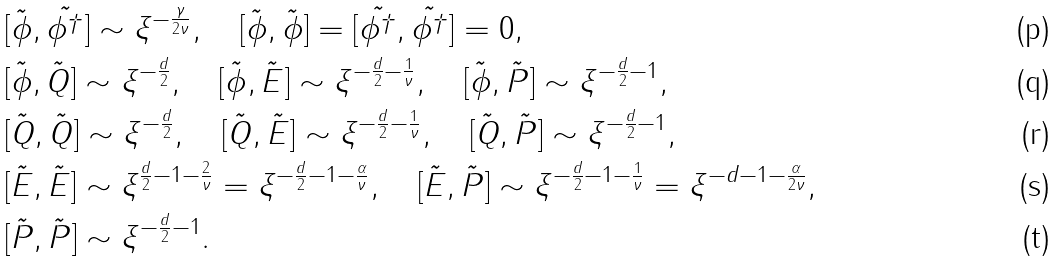<formula> <loc_0><loc_0><loc_500><loc_500>& [ \tilde { \phi } , \tilde { \phi ^ { \dagger } } ] \sim \xi ^ { - \frac { \gamma } { 2 \nu } } , \quad [ \tilde { \phi } , \tilde { \phi } ] = [ \tilde { \phi ^ { \dagger } } , \tilde { \phi ^ { \dagger } } ] = 0 , \\ & [ \tilde { \phi } , \tilde { Q } ] \sim \xi ^ { - \frac { d } { 2 } } , \quad [ \tilde { \phi } , \tilde { E } ] \sim \xi ^ { - \frac { d } { 2 } - \frac { 1 } { \nu } } , \quad [ \tilde { \phi } , \tilde { P } ] \sim \xi ^ { - \frac { d } { 2 } - 1 } , \\ & [ \tilde { Q } , \tilde { Q } ] \sim \xi ^ { - \frac { d } { 2 } } , \quad [ \tilde { Q } , \tilde { E } ] \sim \xi ^ { - \frac { d } { 2 } - \frac { 1 } { \nu } } , \quad [ \tilde { Q } , \tilde { P } ] \sim \xi ^ { - \frac { d } { 2 } - 1 } , \\ & [ \tilde { E } , \tilde { E } ] \sim \xi ^ { \frac { d } { 2 } - 1 - \frac { 2 } { \nu } } = \xi ^ { - \frac { d } { 2 } - 1 - \frac { \alpha } { \nu } } , \quad [ \tilde { E } , \tilde { P } ] \sim \xi ^ { - \frac { d } { 2 } - 1 - \frac { 1 } { \nu } } = \xi ^ { - d - 1 - \frac { \alpha } { 2 \nu } } , \\ & [ \tilde { P } , \tilde { P } ] \sim \xi ^ { - \frac { d } { 2 } - 1 } .</formula> 